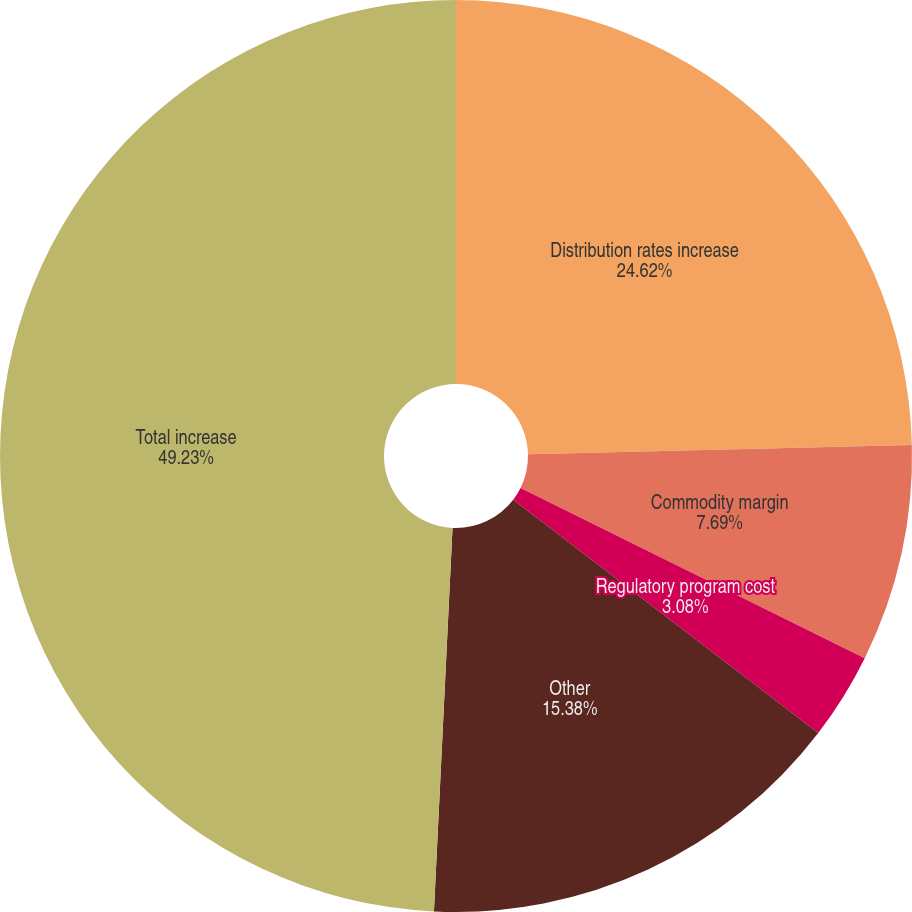Convert chart to OTSL. <chart><loc_0><loc_0><loc_500><loc_500><pie_chart><fcel>Distribution rates increase<fcel>Commodity margin<fcel>Regulatory program cost<fcel>Other<fcel>Total increase<nl><fcel>24.62%<fcel>7.69%<fcel>3.08%<fcel>15.38%<fcel>49.23%<nl></chart> 